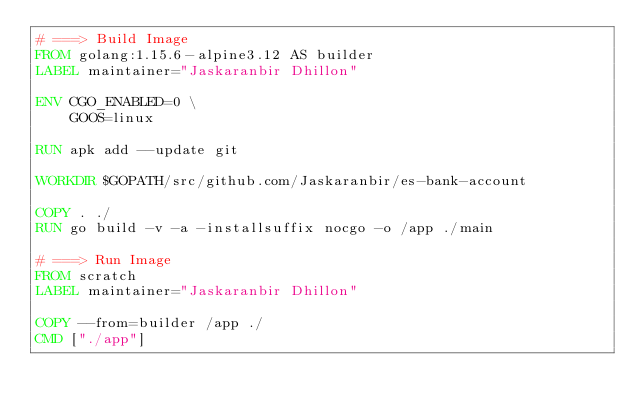<code> <loc_0><loc_0><loc_500><loc_500><_Dockerfile_># ===> Build Image
FROM golang:1.15.6-alpine3.12 AS builder
LABEL maintainer="Jaskaranbir Dhillon"

ENV CGO_ENABLED=0 \
    GOOS=linux

RUN apk add --update git

WORKDIR $GOPATH/src/github.com/Jaskaranbir/es-bank-account

COPY . ./
RUN go build -v -a -installsuffix nocgo -o /app ./main

# ===> Run Image
FROM scratch
LABEL maintainer="Jaskaranbir Dhillon"

COPY --from=builder /app ./
CMD ["./app"]
</code> 